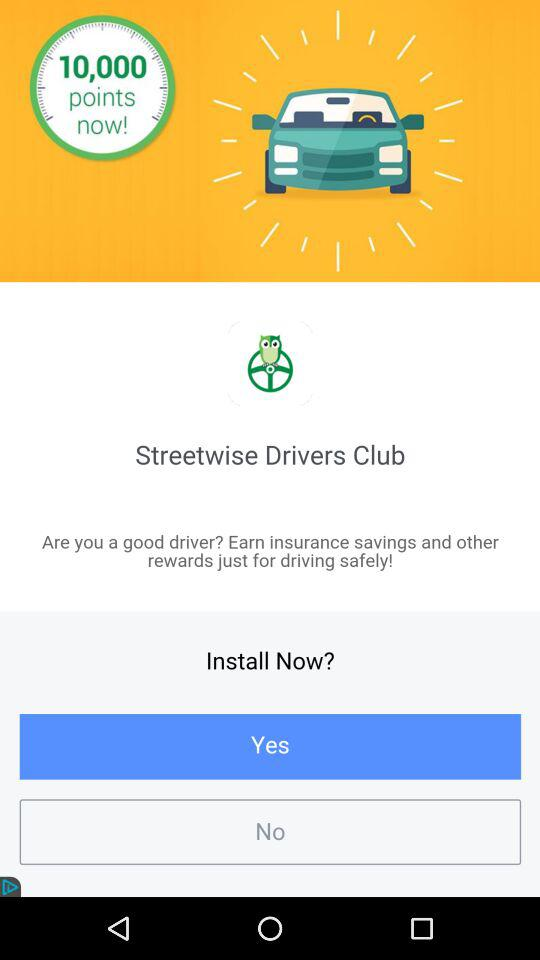How many points are offered by the app?
Answer the question using a single word or phrase. 10,000 